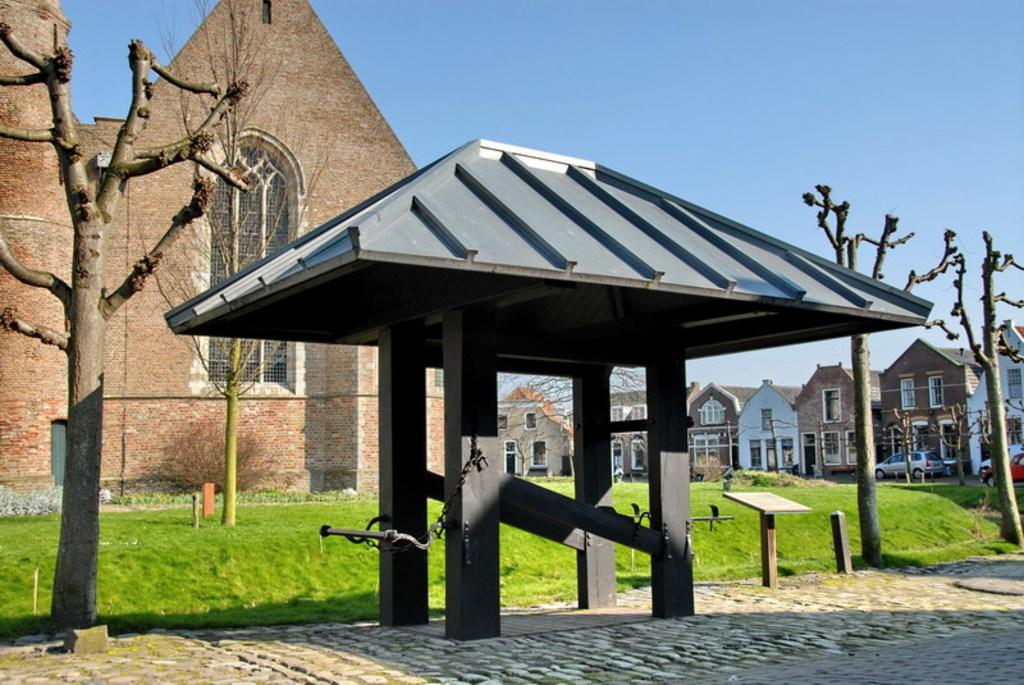What can be seen in the foreground of the image? There are trees and a shed in the foreground of the image. What is visible in the background of the image? There are houses, grassland, vehicles, and sky visible in the background of the image. What type of vegetation is present in the foreground? There are trees in the foreground of the image. What might be used for transportation in the background? Vehicles are present in the background of the image. Where is the crib located in the image? There is no crib present in the image. What type of pain is being experienced by the trees in the foreground? There is no indication of pain being experienced by the trees in the image; they are simply visible in the foreground. 